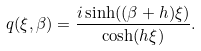Convert formula to latex. <formula><loc_0><loc_0><loc_500><loc_500>q ( \xi , \beta ) = \frac { i \sinh ( ( \beta + h ) \xi ) } { \cosh ( h \xi ) } .</formula> 